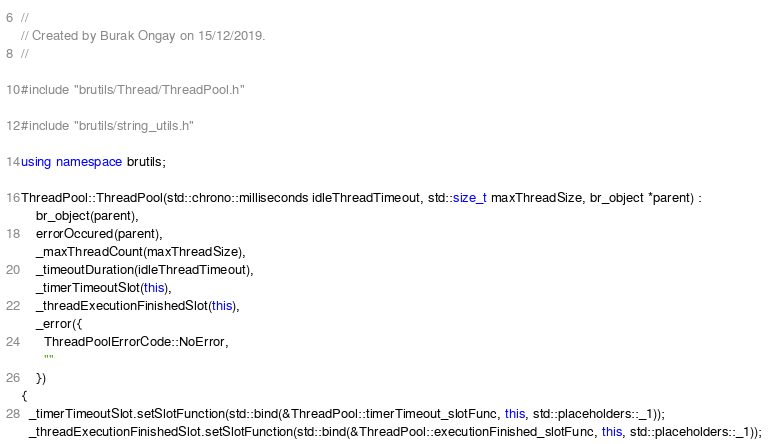Convert code to text. <code><loc_0><loc_0><loc_500><loc_500><_C++_>//
// Created by Burak Ongay on 15/12/2019.
//

#include "brutils/Thread/ThreadPool.h"

#include "brutils/string_utils.h"

using namespace brutils;

ThreadPool::ThreadPool(std::chrono::milliseconds idleThreadTimeout, std::size_t maxThreadSize, br_object *parent) :
    br_object(parent),
    errorOccured(parent),
    _maxThreadCount(maxThreadSize),
    _timeoutDuration(idleThreadTimeout),
    _timerTimeoutSlot(this),
    _threadExecutionFinishedSlot(this),
    _error({
      ThreadPoolErrorCode::NoError,
      ""
    })
{
  _timerTimeoutSlot.setSlotFunction(std::bind(&ThreadPool::timerTimeout_slotFunc, this, std::placeholders::_1));
  _threadExecutionFinishedSlot.setSlotFunction(std::bind(&ThreadPool::executionFinished_slotFunc, this, std::placeholders::_1));
</code> 